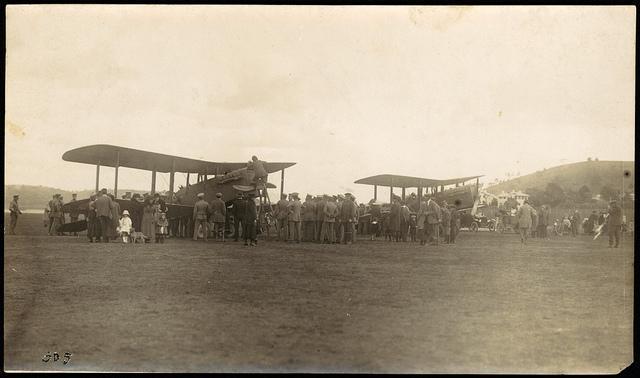How many elephant trunks can you see in the picture?
Give a very brief answer. 0. 